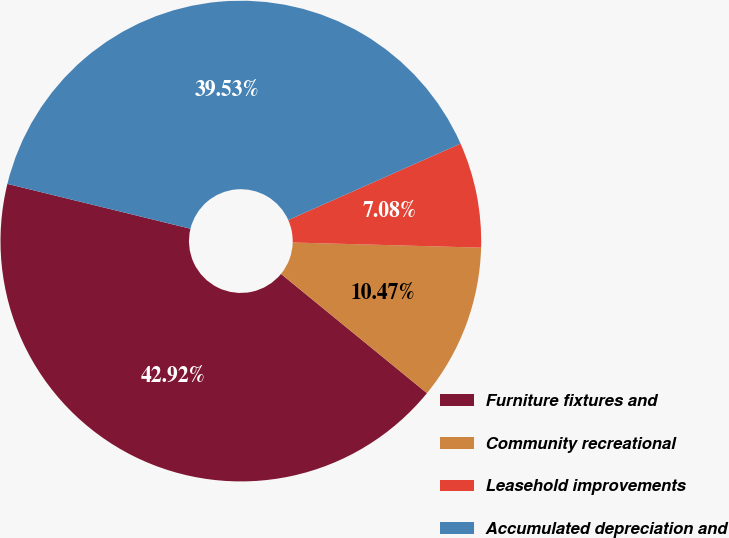<chart> <loc_0><loc_0><loc_500><loc_500><pie_chart><fcel>Furniture fixtures and<fcel>Community recreational<fcel>Leasehold improvements<fcel>Accumulated depreciation and<nl><fcel>42.92%<fcel>10.47%<fcel>7.08%<fcel>39.53%<nl></chart> 